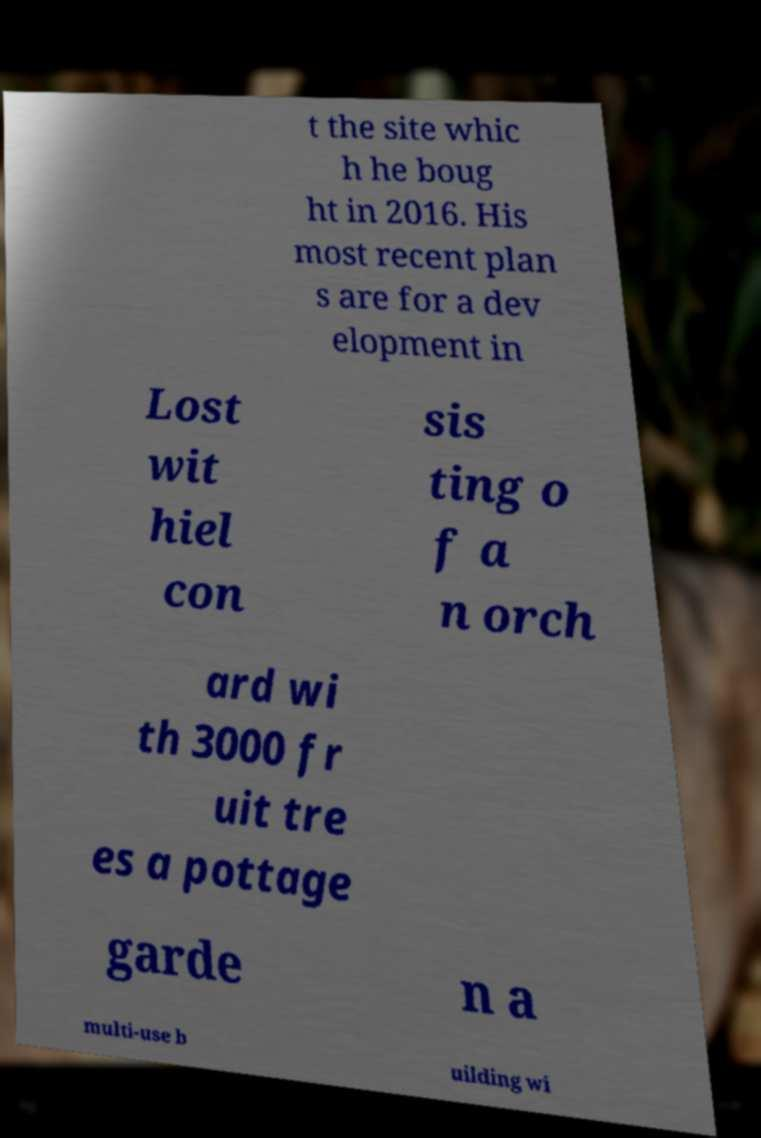There's text embedded in this image that I need extracted. Can you transcribe it verbatim? t the site whic h he boug ht in 2016. His most recent plan s are for a dev elopment in Lost wit hiel con sis ting o f a n orch ard wi th 3000 fr uit tre es a pottage garde n a multi-use b uilding wi 